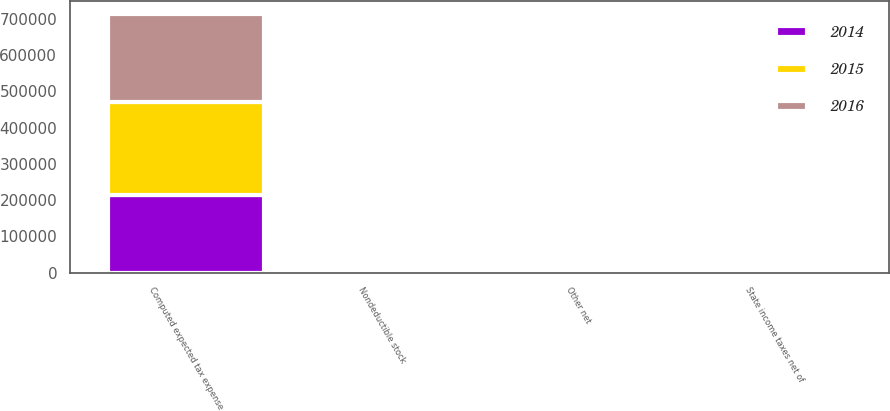Convert chart. <chart><loc_0><loc_0><loc_500><loc_500><stacked_bar_chart><ecel><fcel>Computed expected tax expense<fcel>State income taxes net of<fcel>Nondeductible stock<fcel>Other net<nl><fcel>2016<fcel>240400<fcel>9759<fcel>3629<fcel>535<nl><fcel>2015<fcel>257841<fcel>11272<fcel>5241<fcel>2838<nl><fcel>2014<fcel>213811<fcel>10751<fcel>8069<fcel>1202<nl></chart> 